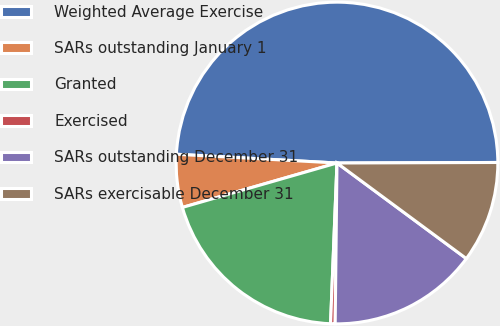<chart> <loc_0><loc_0><loc_500><loc_500><pie_chart><fcel>Weighted Average Exercise<fcel>SARs outstanding January 1<fcel>Granted<fcel>Exercised<fcel>SARs outstanding December 31<fcel>SARs exercisable December 31<nl><fcel>49.08%<fcel>5.32%<fcel>19.91%<fcel>0.46%<fcel>15.05%<fcel>10.18%<nl></chart> 